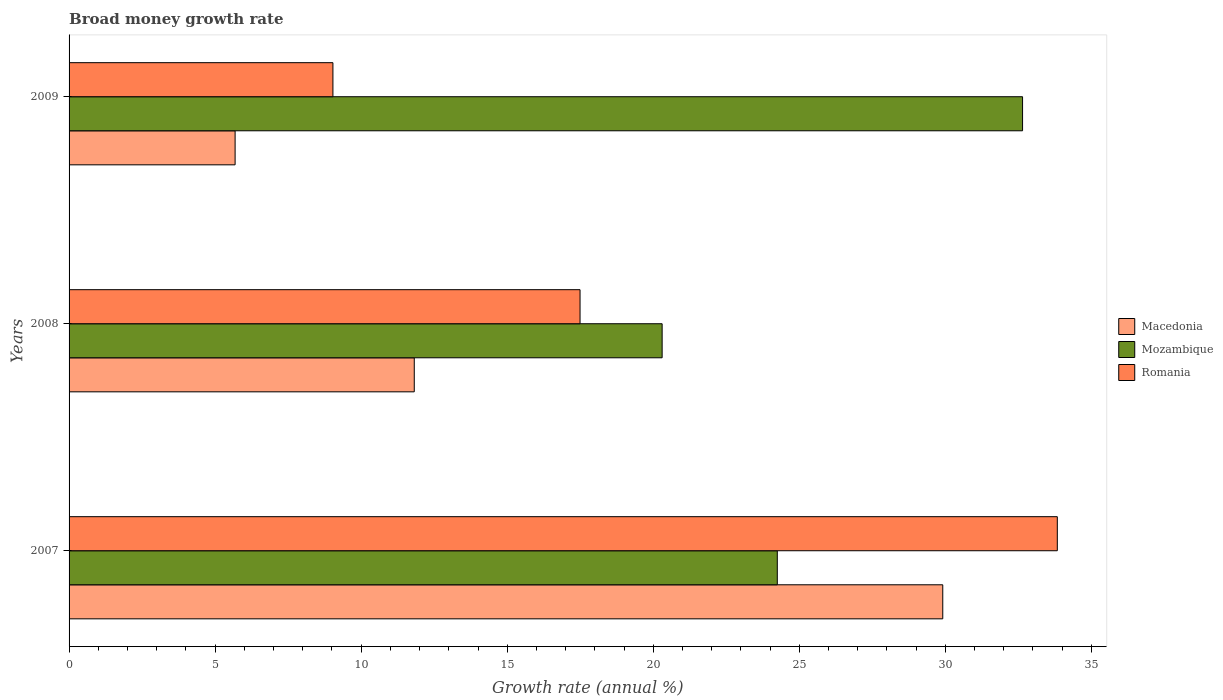Are the number of bars on each tick of the Y-axis equal?
Ensure brevity in your answer.  Yes. How many bars are there on the 1st tick from the top?
Your answer should be compact. 3. How many bars are there on the 2nd tick from the bottom?
Keep it short and to the point. 3. In how many cases, is the number of bars for a given year not equal to the number of legend labels?
Make the answer very short. 0. What is the growth rate in Mozambique in 2008?
Give a very brief answer. 20.3. Across all years, what is the maximum growth rate in Macedonia?
Make the answer very short. 29.91. Across all years, what is the minimum growth rate in Mozambique?
Your answer should be very brief. 20.3. In which year was the growth rate in Macedonia maximum?
Your answer should be very brief. 2007. What is the total growth rate in Mozambique in the graph?
Provide a succinct answer. 77.2. What is the difference between the growth rate in Mozambique in 2007 and that in 2008?
Provide a short and direct response. 3.94. What is the difference between the growth rate in Mozambique in 2009 and the growth rate in Macedonia in 2007?
Give a very brief answer. 2.73. What is the average growth rate in Macedonia per year?
Give a very brief answer. 15.8. In the year 2008, what is the difference between the growth rate in Romania and growth rate in Macedonia?
Give a very brief answer. 5.68. In how many years, is the growth rate in Romania greater than 27 %?
Provide a succinct answer. 1. What is the ratio of the growth rate in Mozambique in 2007 to that in 2008?
Ensure brevity in your answer.  1.19. Is the difference between the growth rate in Romania in 2007 and 2009 greater than the difference between the growth rate in Macedonia in 2007 and 2009?
Give a very brief answer. Yes. What is the difference between the highest and the second highest growth rate in Macedonia?
Keep it short and to the point. 18.09. What is the difference between the highest and the lowest growth rate in Macedonia?
Provide a succinct answer. 24.23. What does the 1st bar from the top in 2008 represents?
Make the answer very short. Romania. What does the 1st bar from the bottom in 2008 represents?
Give a very brief answer. Macedonia. How many bars are there?
Your answer should be very brief. 9. Are all the bars in the graph horizontal?
Offer a terse response. Yes. What is the difference between two consecutive major ticks on the X-axis?
Provide a succinct answer. 5. Does the graph contain any zero values?
Offer a terse response. No. Does the graph contain grids?
Keep it short and to the point. No. What is the title of the graph?
Give a very brief answer. Broad money growth rate. Does "Bahamas" appear as one of the legend labels in the graph?
Make the answer very short. No. What is the label or title of the X-axis?
Ensure brevity in your answer.  Growth rate (annual %). What is the label or title of the Y-axis?
Your answer should be compact. Years. What is the Growth rate (annual %) of Macedonia in 2007?
Give a very brief answer. 29.91. What is the Growth rate (annual %) in Mozambique in 2007?
Keep it short and to the point. 24.25. What is the Growth rate (annual %) of Romania in 2007?
Offer a terse response. 33.83. What is the Growth rate (annual %) in Macedonia in 2008?
Provide a succinct answer. 11.82. What is the Growth rate (annual %) of Mozambique in 2008?
Provide a succinct answer. 20.3. What is the Growth rate (annual %) in Romania in 2008?
Provide a succinct answer. 17.49. What is the Growth rate (annual %) in Macedonia in 2009?
Give a very brief answer. 5.68. What is the Growth rate (annual %) in Mozambique in 2009?
Provide a short and direct response. 32.64. What is the Growth rate (annual %) in Romania in 2009?
Ensure brevity in your answer.  9.03. Across all years, what is the maximum Growth rate (annual %) of Macedonia?
Provide a short and direct response. 29.91. Across all years, what is the maximum Growth rate (annual %) in Mozambique?
Make the answer very short. 32.64. Across all years, what is the maximum Growth rate (annual %) of Romania?
Make the answer very short. 33.83. Across all years, what is the minimum Growth rate (annual %) of Macedonia?
Offer a very short reply. 5.68. Across all years, what is the minimum Growth rate (annual %) of Mozambique?
Your answer should be compact. 20.3. Across all years, what is the minimum Growth rate (annual %) of Romania?
Keep it short and to the point. 9.03. What is the total Growth rate (annual %) of Macedonia in the graph?
Provide a succinct answer. 47.41. What is the total Growth rate (annual %) in Mozambique in the graph?
Provide a succinct answer. 77.2. What is the total Growth rate (annual %) in Romania in the graph?
Your answer should be very brief. 60.36. What is the difference between the Growth rate (annual %) of Macedonia in 2007 and that in 2008?
Provide a succinct answer. 18.09. What is the difference between the Growth rate (annual %) in Mozambique in 2007 and that in 2008?
Give a very brief answer. 3.94. What is the difference between the Growth rate (annual %) of Romania in 2007 and that in 2008?
Offer a terse response. 16.34. What is the difference between the Growth rate (annual %) in Macedonia in 2007 and that in 2009?
Offer a terse response. 24.23. What is the difference between the Growth rate (annual %) of Mozambique in 2007 and that in 2009?
Your answer should be compact. -8.4. What is the difference between the Growth rate (annual %) in Romania in 2007 and that in 2009?
Offer a terse response. 24.8. What is the difference between the Growth rate (annual %) of Macedonia in 2008 and that in 2009?
Your answer should be very brief. 6.13. What is the difference between the Growth rate (annual %) in Mozambique in 2008 and that in 2009?
Keep it short and to the point. -12.34. What is the difference between the Growth rate (annual %) in Romania in 2008 and that in 2009?
Your response must be concise. 8.46. What is the difference between the Growth rate (annual %) of Macedonia in 2007 and the Growth rate (annual %) of Mozambique in 2008?
Make the answer very short. 9.61. What is the difference between the Growth rate (annual %) in Macedonia in 2007 and the Growth rate (annual %) in Romania in 2008?
Make the answer very short. 12.42. What is the difference between the Growth rate (annual %) in Mozambique in 2007 and the Growth rate (annual %) in Romania in 2008?
Offer a terse response. 6.75. What is the difference between the Growth rate (annual %) of Macedonia in 2007 and the Growth rate (annual %) of Mozambique in 2009?
Ensure brevity in your answer.  -2.73. What is the difference between the Growth rate (annual %) in Macedonia in 2007 and the Growth rate (annual %) in Romania in 2009?
Your answer should be compact. 20.88. What is the difference between the Growth rate (annual %) in Mozambique in 2007 and the Growth rate (annual %) in Romania in 2009?
Your answer should be compact. 15.21. What is the difference between the Growth rate (annual %) of Macedonia in 2008 and the Growth rate (annual %) of Mozambique in 2009?
Ensure brevity in your answer.  -20.83. What is the difference between the Growth rate (annual %) in Macedonia in 2008 and the Growth rate (annual %) in Romania in 2009?
Offer a very short reply. 2.78. What is the difference between the Growth rate (annual %) in Mozambique in 2008 and the Growth rate (annual %) in Romania in 2009?
Your answer should be very brief. 11.27. What is the average Growth rate (annual %) in Macedonia per year?
Give a very brief answer. 15.8. What is the average Growth rate (annual %) of Mozambique per year?
Offer a very short reply. 25.73. What is the average Growth rate (annual %) of Romania per year?
Offer a terse response. 20.12. In the year 2007, what is the difference between the Growth rate (annual %) of Macedonia and Growth rate (annual %) of Mozambique?
Your answer should be compact. 5.66. In the year 2007, what is the difference between the Growth rate (annual %) of Macedonia and Growth rate (annual %) of Romania?
Offer a very short reply. -3.92. In the year 2007, what is the difference between the Growth rate (annual %) of Mozambique and Growth rate (annual %) of Romania?
Make the answer very short. -9.59. In the year 2008, what is the difference between the Growth rate (annual %) in Macedonia and Growth rate (annual %) in Mozambique?
Make the answer very short. -8.49. In the year 2008, what is the difference between the Growth rate (annual %) in Macedonia and Growth rate (annual %) in Romania?
Your response must be concise. -5.68. In the year 2008, what is the difference between the Growth rate (annual %) of Mozambique and Growth rate (annual %) of Romania?
Offer a very short reply. 2.81. In the year 2009, what is the difference between the Growth rate (annual %) of Macedonia and Growth rate (annual %) of Mozambique?
Offer a terse response. -26.96. In the year 2009, what is the difference between the Growth rate (annual %) of Macedonia and Growth rate (annual %) of Romania?
Make the answer very short. -3.35. In the year 2009, what is the difference between the Growth rate (annual %) in Mozambique and Growth rate (annual %) in Romania?
Your answer should be compact. 23.61. What is the ratio of the Growth rate (annual %) in Macedonia in 2007 to that in 2008?
Your answer should be compact. 2.53. What is the ratio of the Growth rate (annual %) of Mozambique in 2007 to that in 2008?
Your answer should be compact. 1.19. What is the ratio of the Growth rate (annual %) of Romania in 2007 to that in 2008?
Your response must be concise. 1.93. What is the ratio of the Growth rate (annual %) of Macedonia in 2007 to that in 2009?
Your response must be concise. 5.26. What is the ratio of the Growth rate (annual %) of Mozambique in 2007 to that in 2009?
Your answer should be very brief. 0.74. What is the ratio of the Growth rate (annual %) in Romania in 2007 to that in 2009?
Your answer should be compact. 3.75. What is the ratio of the Growth rate (annual %) of Macedonia in 2008 to that in 2009?
Keep it short and to the point. 2.08. What is the ratio of the Growth rate (annual %) in Mozambique in 2008 to that in 2009?
Provide a short and direct response. 0.62. What is the ratio of the Growth rate (annual %) of Romania in 2008 to that in 2009?
Provide a succinct answer. 1.94. What is the difference between the highest and the second highest Growth rate (annual %) in Macedonia?
Provide a short and direct response. 18.09. What is the difference between the highest and the second highest Growth rate (annual %) of Mozambique?
Keep it short and to the point. 8.4. What is the difference between the highest and the second highest Growth rate (annual %) in Romania?
Your answer should be compact. 16.34. What is the difference between the highest and the lowest Growth rate (annual %) of Macedonia?
Give a very brief answer. 24.23. What is the difference between the highest and the lowest Growth rate (annual %) of Mozambique?
Your answer should be compact. 12.34. What is the difference between the highest and the lowest Growth rate (annual %) of Romania?
Make the answer very short. 24.8. 